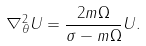Convert formula to latex. <formula><loc_0><loc_0><loc_500><loc_500>\nabla _ { \theta } ^ { 2 } U = \frac { 2 m \Omega } { \sigma - m \Omega } U .</formula> 